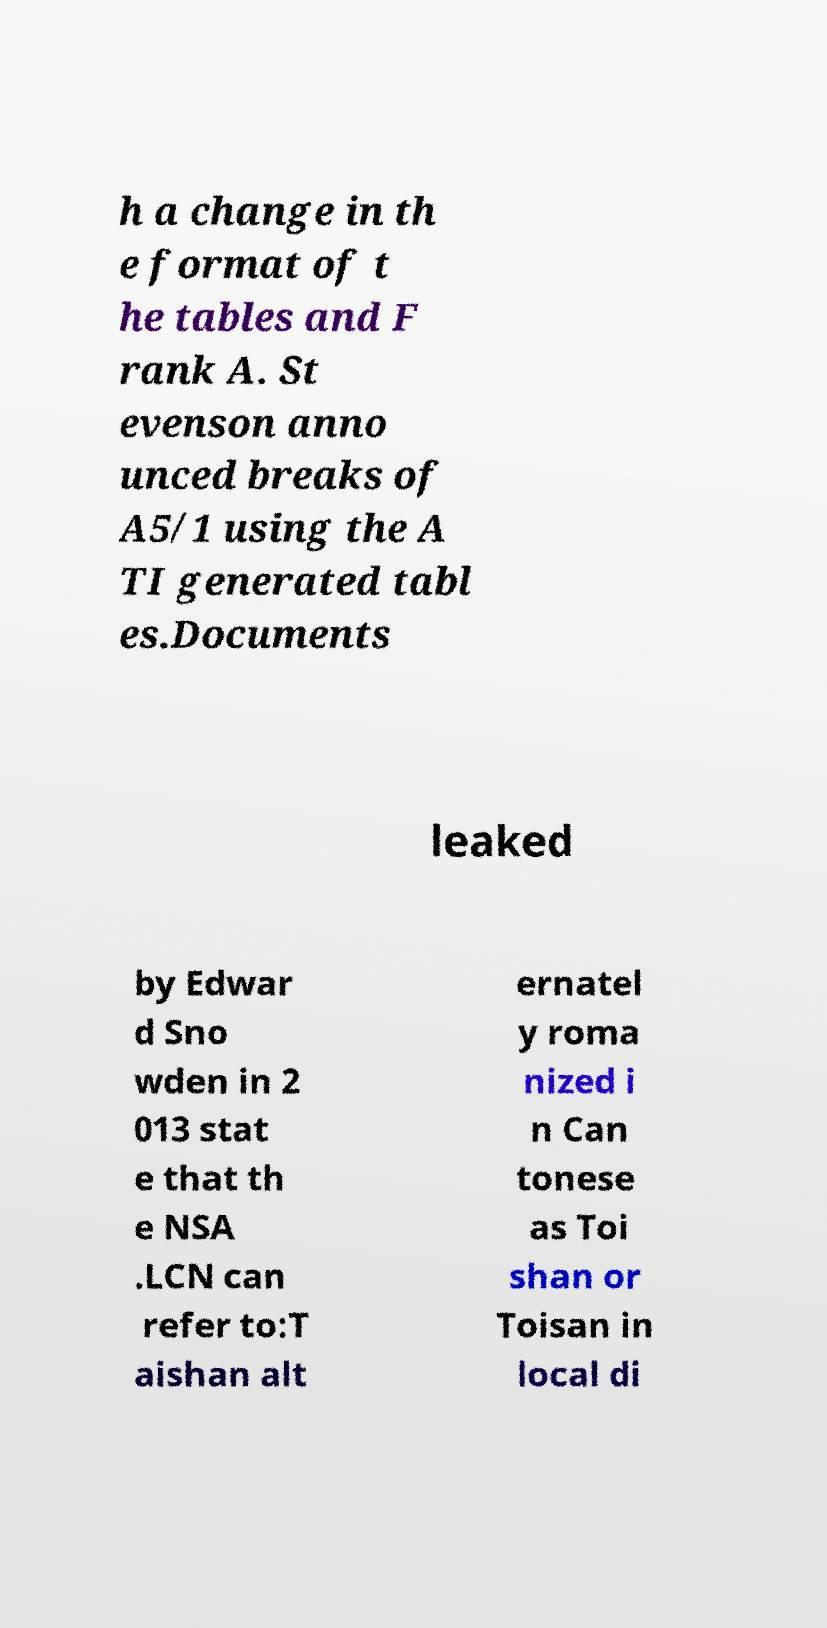What messages or text are displayed in this image? I need them in a readable, typed format. h a change in th e format of t he tables and F rank A. St evenson anno unced breaks of A5/1 using the A TI generated tabl es.Documents leaked by Edwar d Sno wden in 2 013 stat e that th e NSA .LCN can refer to:T aishan alt ernatel y roma nized i n Can tonese as Toi shan or Toisan in local di 